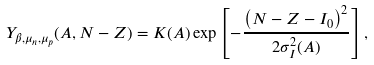<formula> <loc_0><loc_0><loc_500><loc_500>Y _ { \beta , \mu _ { n } , \mu _ { p } } ( A , N - Z ) = K ( A ) \exp \left [ - \frac { \left ( N - Z - I _ { 0 } \right ) ^ { 2 } } { 2 \sigma _ { I } ^ { 2 } ( A ) } \right ] ,</formula> 